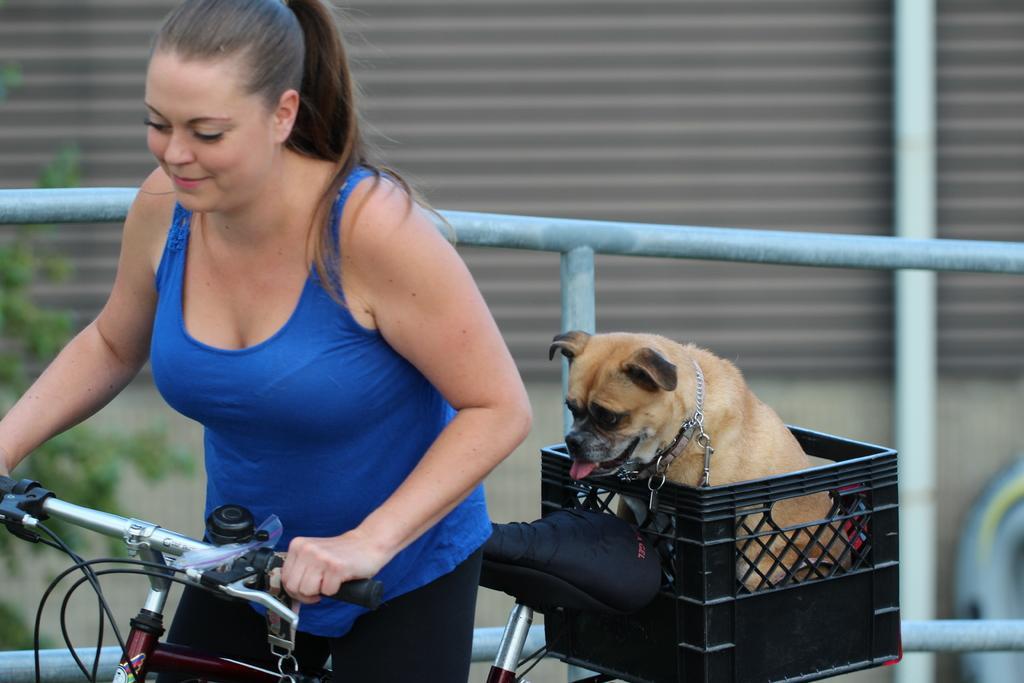How would you summarize this image in a sentence or two? In this picture we can see woman smiling and holding bicycle with her hand and at back of her we can see dog sitting on basket and in background we can see wall, tree, rod. 